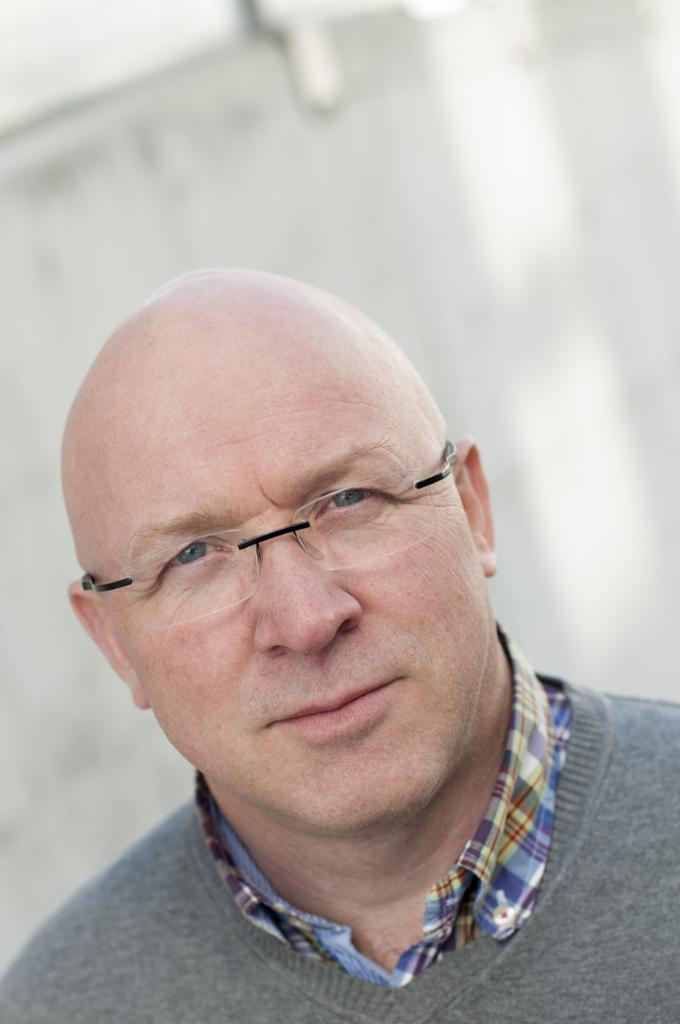What is the main subject of the image? There is a man in the image. What is the man wearing on his upper body? The man is wearing a grey t-shirt and a colorful shirt. What accessory is the man wearing in the image? The man is wearing spectacles. What is the color of the background in the image? The background of the image is white. How many houses can be seen in the image? There are no houses visible in the image; it features a man wearing a grey t-shirt, a colorful shirt, and spectacles against a white background. What type of minister is present in the image? There is no minister present in the image; it features a man wearing a grey t-shirt, a colorful shirt, and spectacles against a white background. 